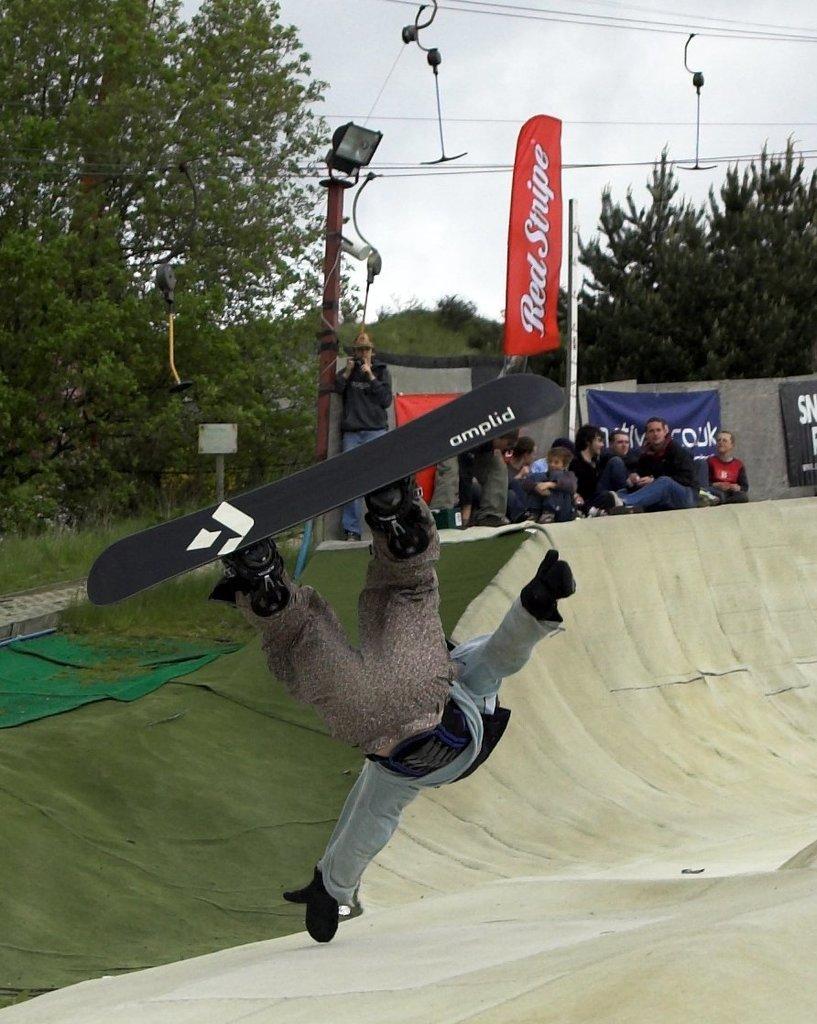How would you summarize this image in a sentence or two? In this image we can see a person is in the air and wore a skateboard. Here we can see banners, poles, wires, people, grass, carpets, surface, and trees. In the background there is sky. 